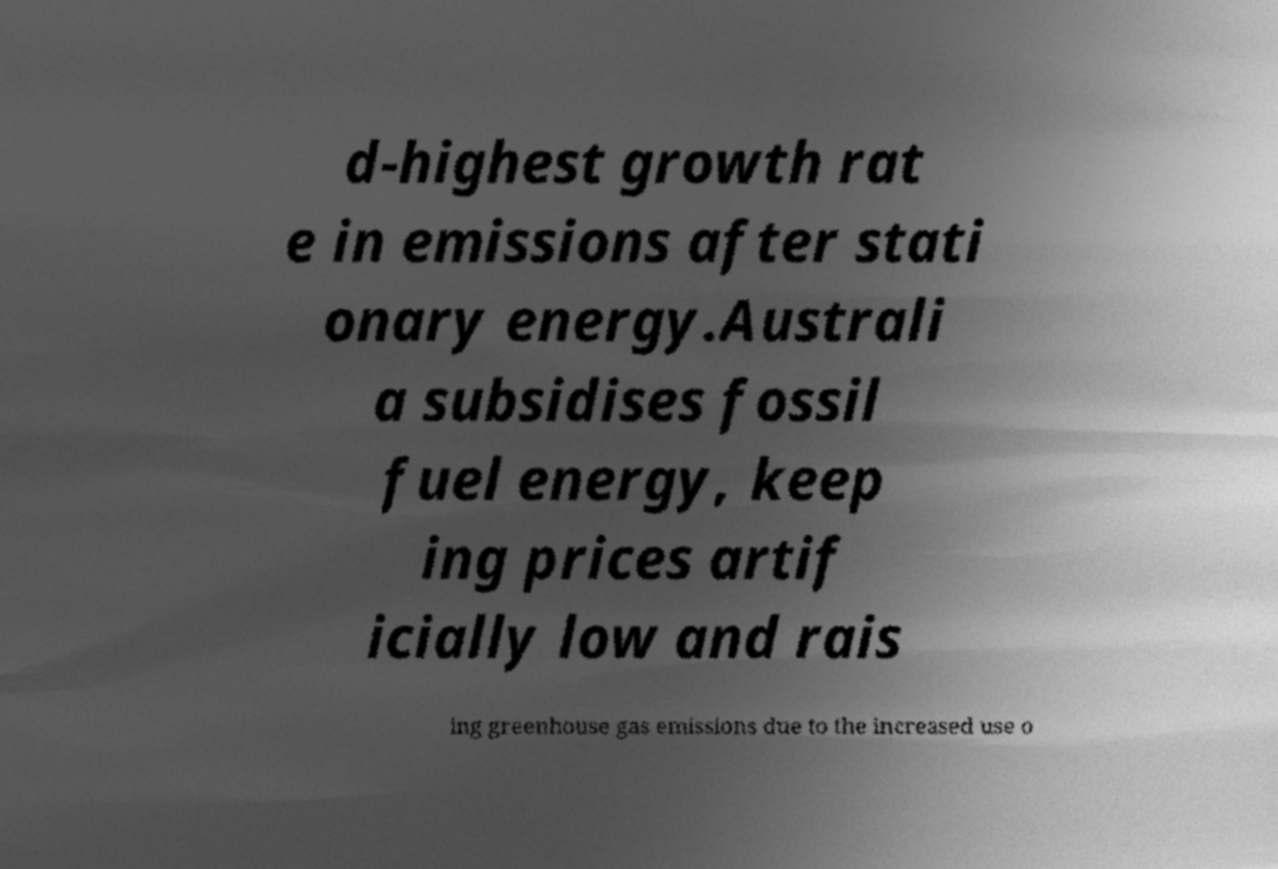There's text embedded in this image that I need extracted. Can you transcribe it verbatim? d-highest growth rat e in emissions after stati onary energy.Australi a subsidises fossil fuel energy, keep ing prices artif icially low and rais ing greenhouse gas emissions due to the increased use o 